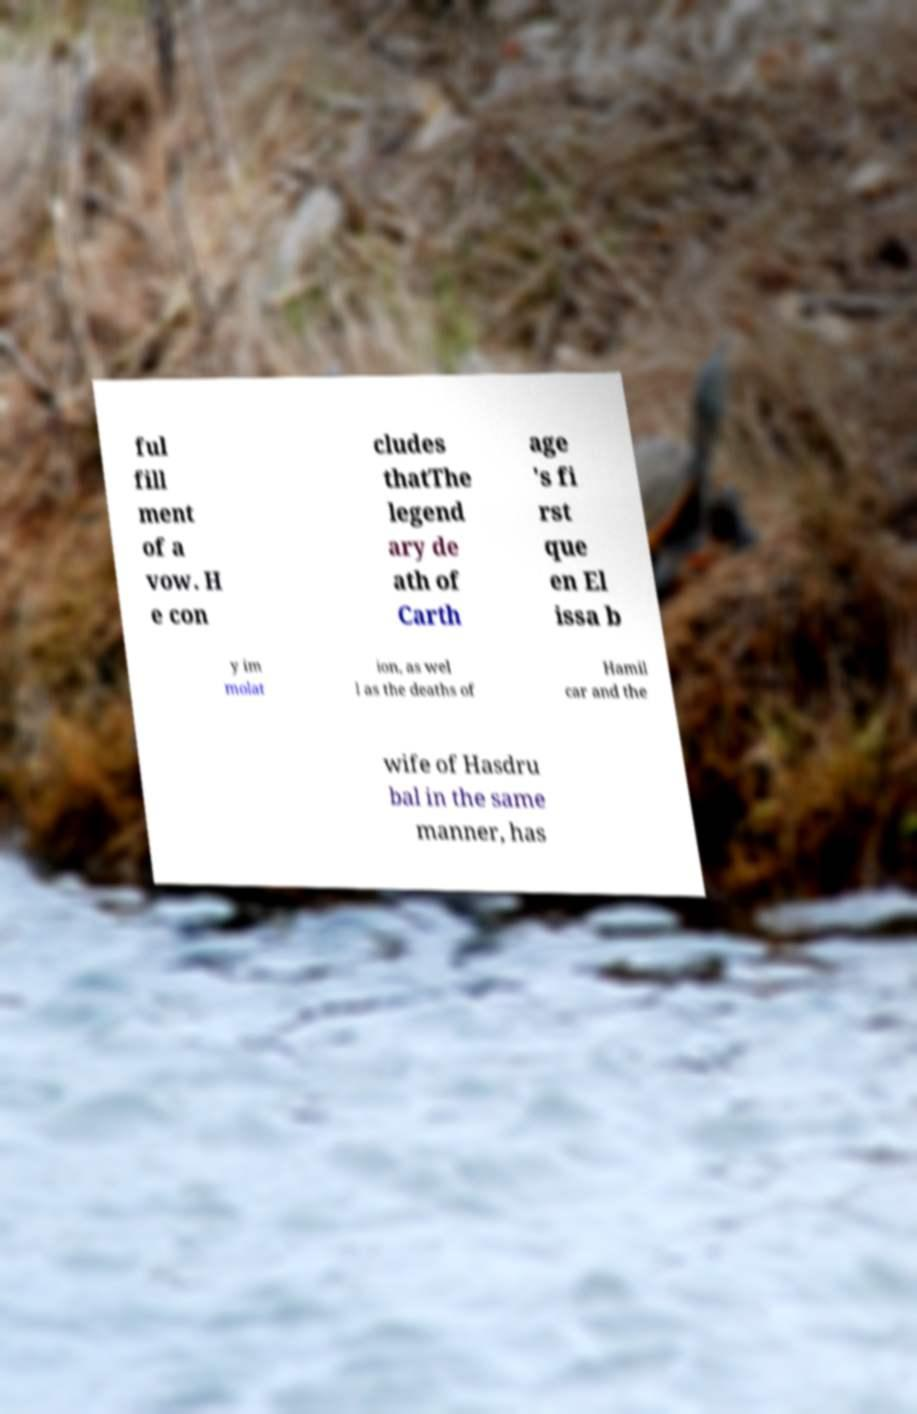What messages or text are displayed in this image? I need them in a readable, typed format. ful fill ment of a vow. H e con cludes thatThe legend ary de ath of Carth age 's fi rst que en El issa b y im molat ion, as wel l as the deaths of Hamil car and the wife of Hasdru bal in the same manner, has 